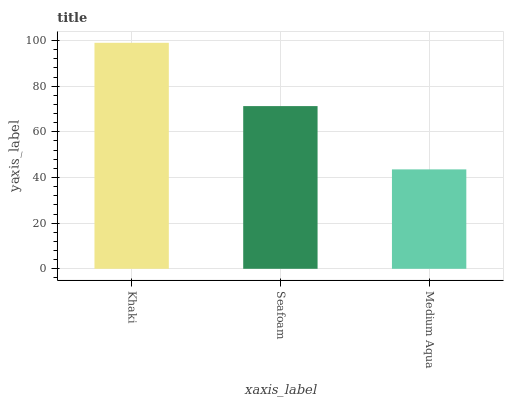Is Medium Aqua the minimum?
Answer yes or no. Yes. Is Khaki the maximum?
Answer yes or no. Yes. Is Seafoam the minimum?
Answer yes or no. No. Is Seafoam the maximum?
Answer yes or no. No. Is Khaki greater than Seafoam?
Answer yes or no. Yes. Is Seafoam less than Khaki?
Answer yes or no. Yes. Is Seafoam greater than Khaki?
Answer yes or no. No. Is Khaki less than Seafoam?
Answer yes or no. No. Is Seafoam the high median?
Answer yes or no. Yes. Is Seafoam the low median?
Answer yes or no. Yes. Is Khaki the high median?
Answer yes or no. No. Is Medium Aqua the low median?
Answer yes or no. No. 